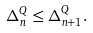<formula> <loc_0><loc_0><loc_500><loc_500>\Delta ^ { Q } _ { n } \leq \Delta _ { n + 1 } ^ { Q } .</formula> 